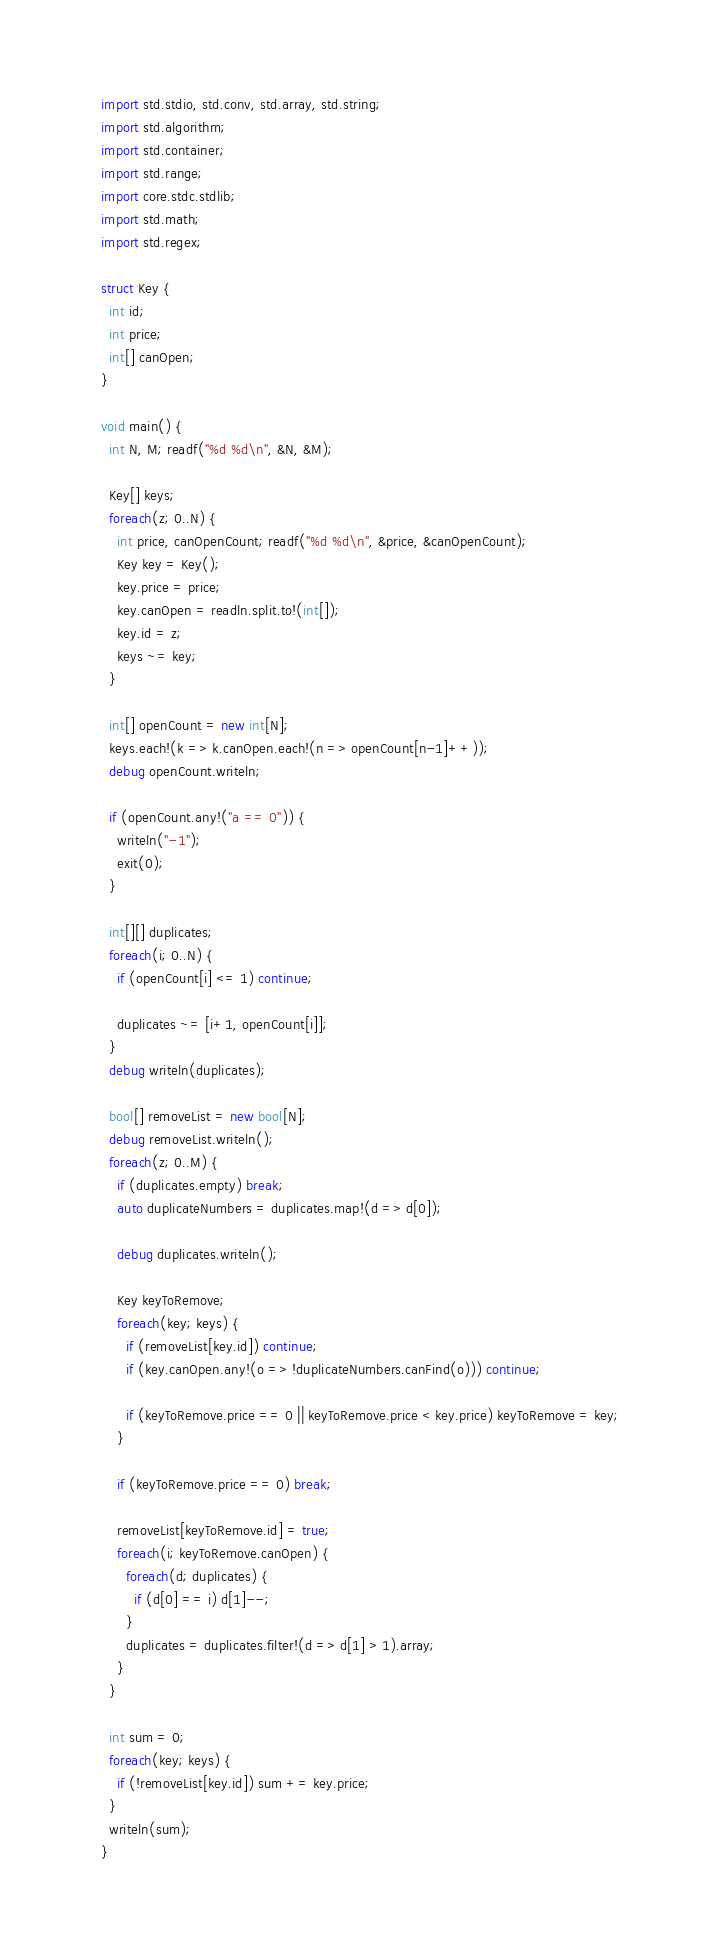<code> <loc_0><loc_0><loc_500><loc_500><_D_>import std.stdio, std.conv, std.array, std.string;
import std.algorithm;
import std.container;
import std.range;
import core.stdc.stdlib;
import std.math;
import std.regex;

struct Key {
  int id;
  int price;
  int[] canOpen;
}

void main() {
  int N, M; readf("%d %d\n", &N, &M);

  Key[] keys;
  foreach(z; 0..N) {
    int price, canOpenCount; readf("%d %d\n", &price, &canOpenCount);
    Key key = Key();
    key.price = price;
    key.canOpen = readln.split.to!(int[]);
    key.id = z;
    keys ~= key;
  }

  int[] openCount = new int[N];
  keys.each!(k => k.canOpen.each!(n => openCount[n-1]++));
  debug openCount.writeln;
  
  if (openCount.any!("a == 0")) {
    writeln("-1");
    exit(0);
  }
  
  int[][] duplicates;
  foreach(i; 0..N) {
    if (openCount[i] <= 1) continue;

    duplicates ~= [i+1, openCount[i]];
  }
  debug writeln(duplicates);

  bool[] removeList = new bool[N];
  debug removeList.writeln();
  foreach(z; 0..M) {
    if (duplicates.empty) break;
    auto duplicateNumbers = duplicates.map!(d => d[0]);

    debug duplicates.writeln();

    Key keyToRemove;
    foreach(key; keys) {
      if (removeList[key.id]) continue;
      if (key.canOpen.any!(o => !duplicateNumbers.canFind(o))) continue;

      if (keyToRemove.price == 0 || keyToRemove.price < key.price) keyToRemove = key;
    }

    if (keyToRemove.price == 0) break;

    removeList[keyToRemove.id] = true;
    foreach(i; keyToRemove.canOpen) {
      foreach(d; duplicates) {
        if (d[0] == i) d[1]--;
      }
      duplicates = duplicates.filter!(d => d[1] > 1).array;
    }
  }

  int sum = 0;
  foreach(key; keys) {
    if (!removeList[key.id]) sum += key.price;
  }
  writeln(sum);
}</code> 